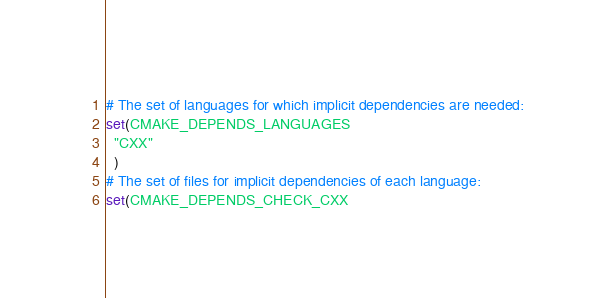Convert code to text. <code><loc_0><loc_0><loc_500><loc_500><_CMake_># The set of languages for which implicit dependencies are needed:
set(CMAKE_DEPENDS_LANGUAGES
  "CXX"
  )
# The set of files for implicit dependencies of each language:
set(CMAKE_DEPENDS_CHECK_CXX</code> 